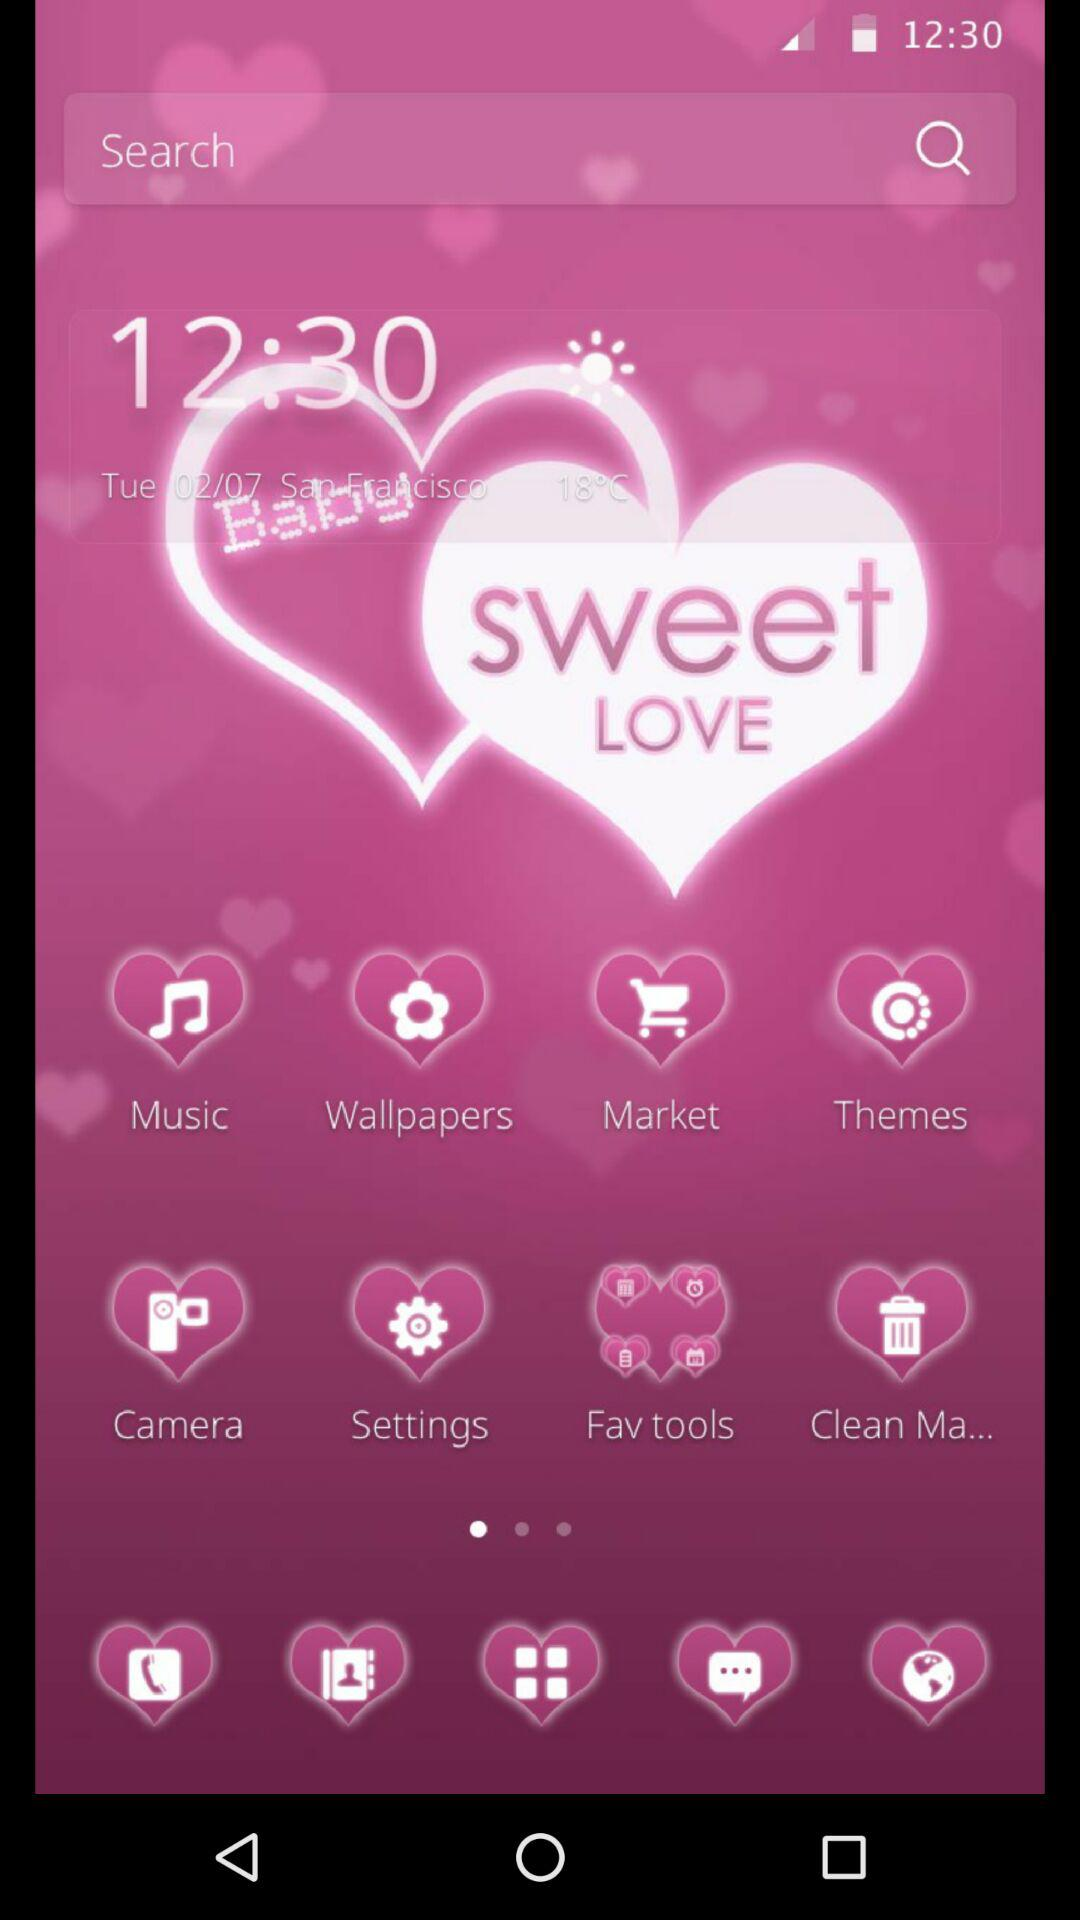How many applications are there?
When the provided information is insufficient, respond with <no answer>. <no answer> 